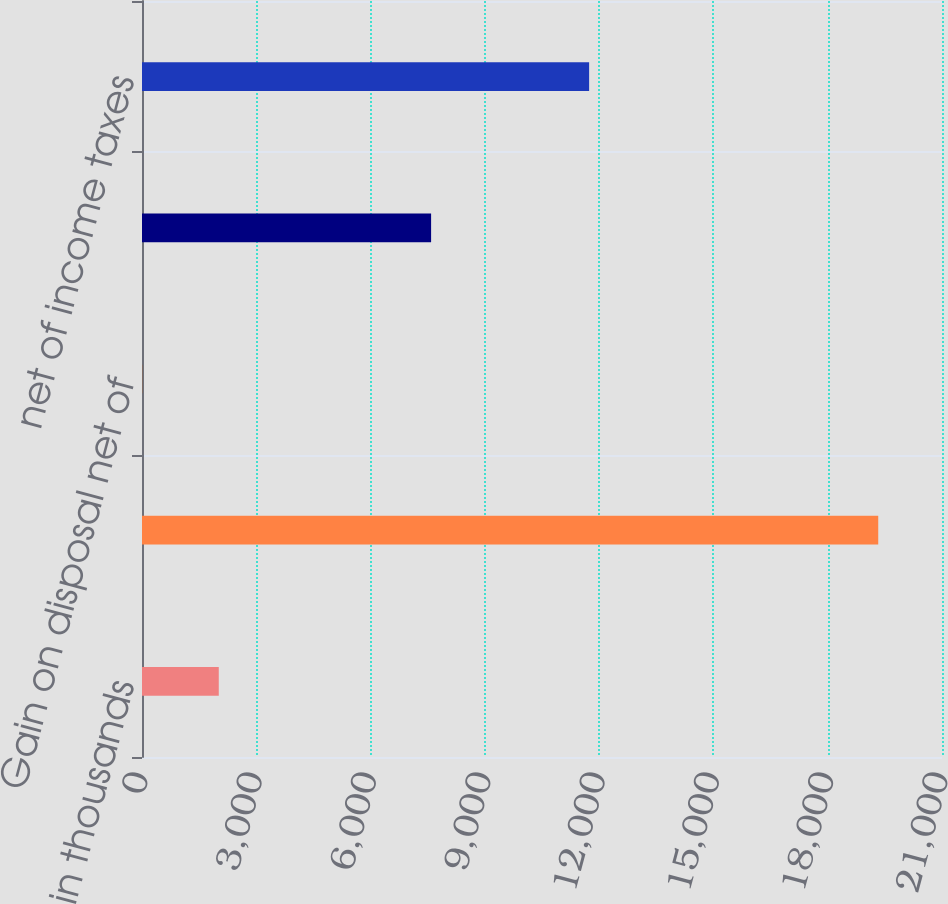Convert chart to OTSL. <chart><loc_0><loc_0><loc_500><loc_500><bar_chart><fcel>in thousands<fcel>Pretax loss<fcel>Gain on disposal net of<fcel>Income tax (provision) benefit<fcel>net of income taxes<nl><fcel>2015<fcel>19326<fcel>4.36<fcel>7589<fcel>11737<nl></chart> 